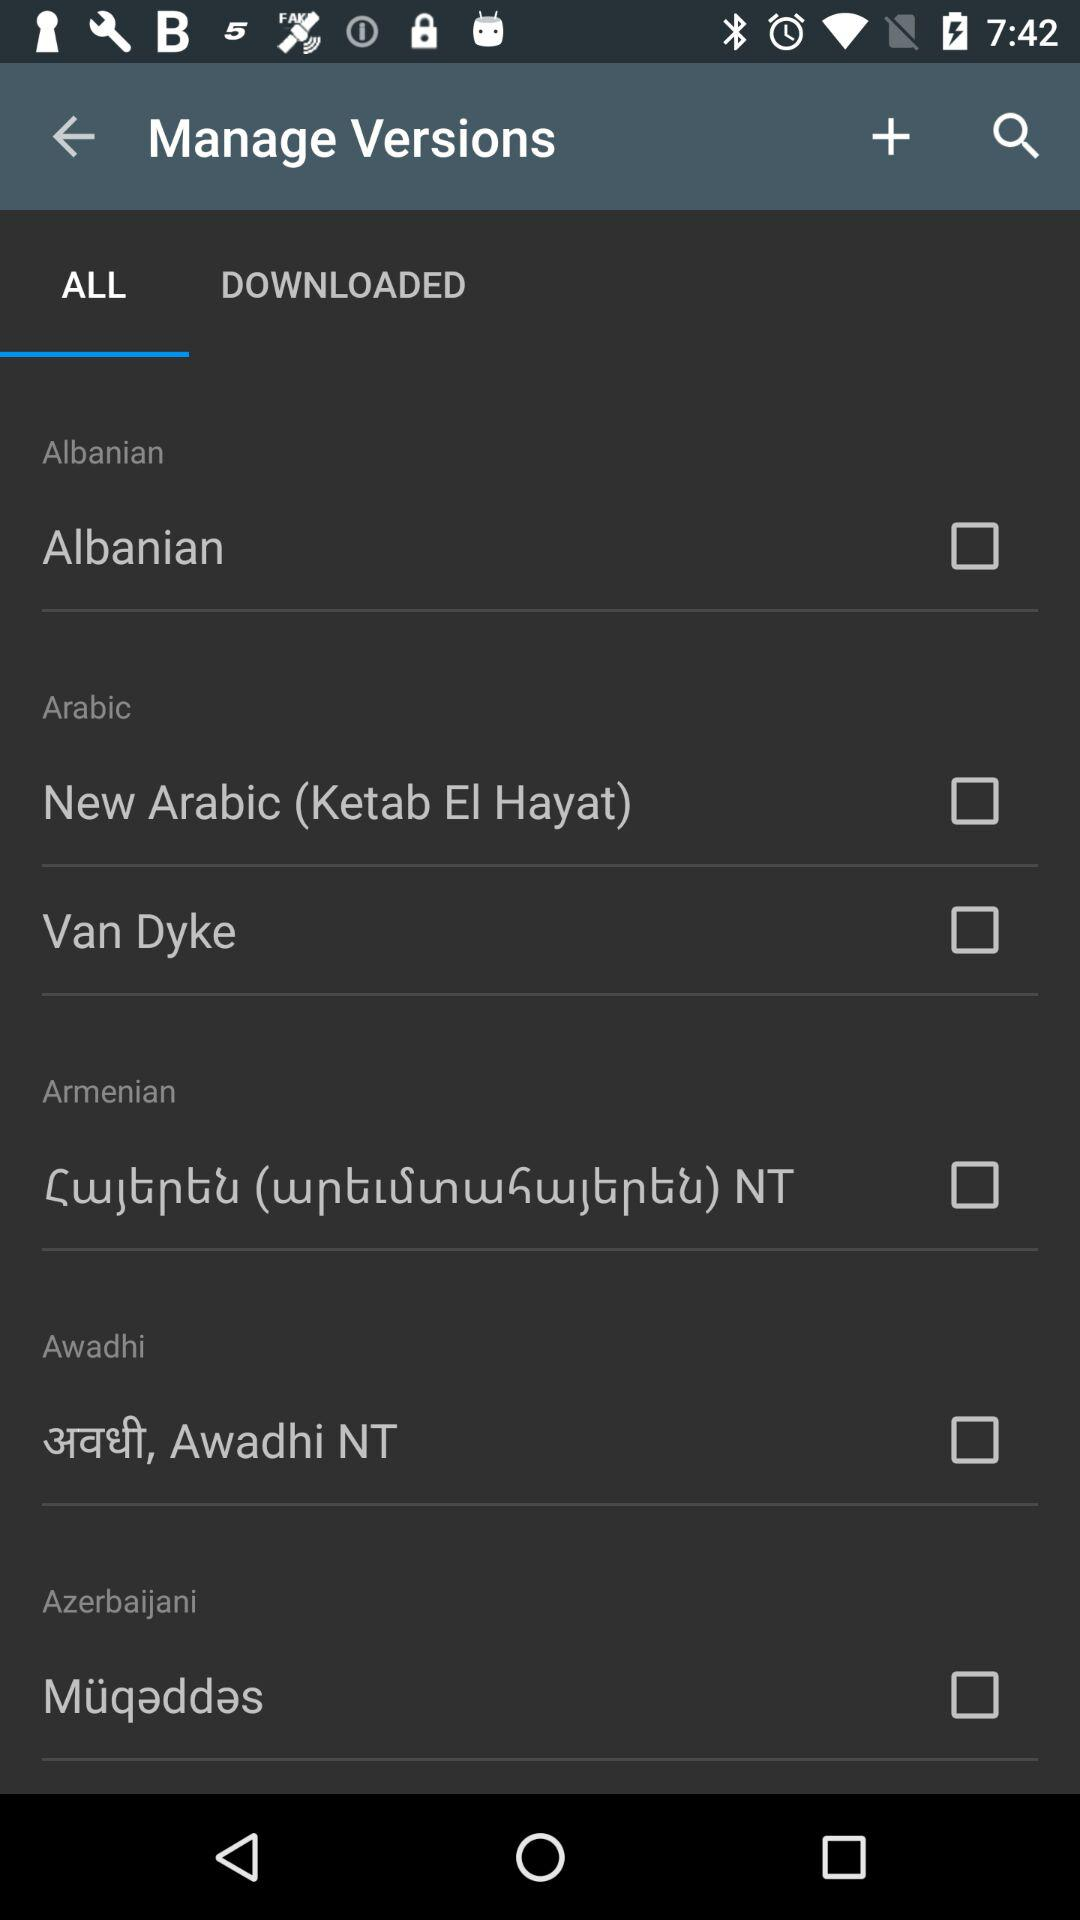Which option is selected? The selected option is "ALL". 